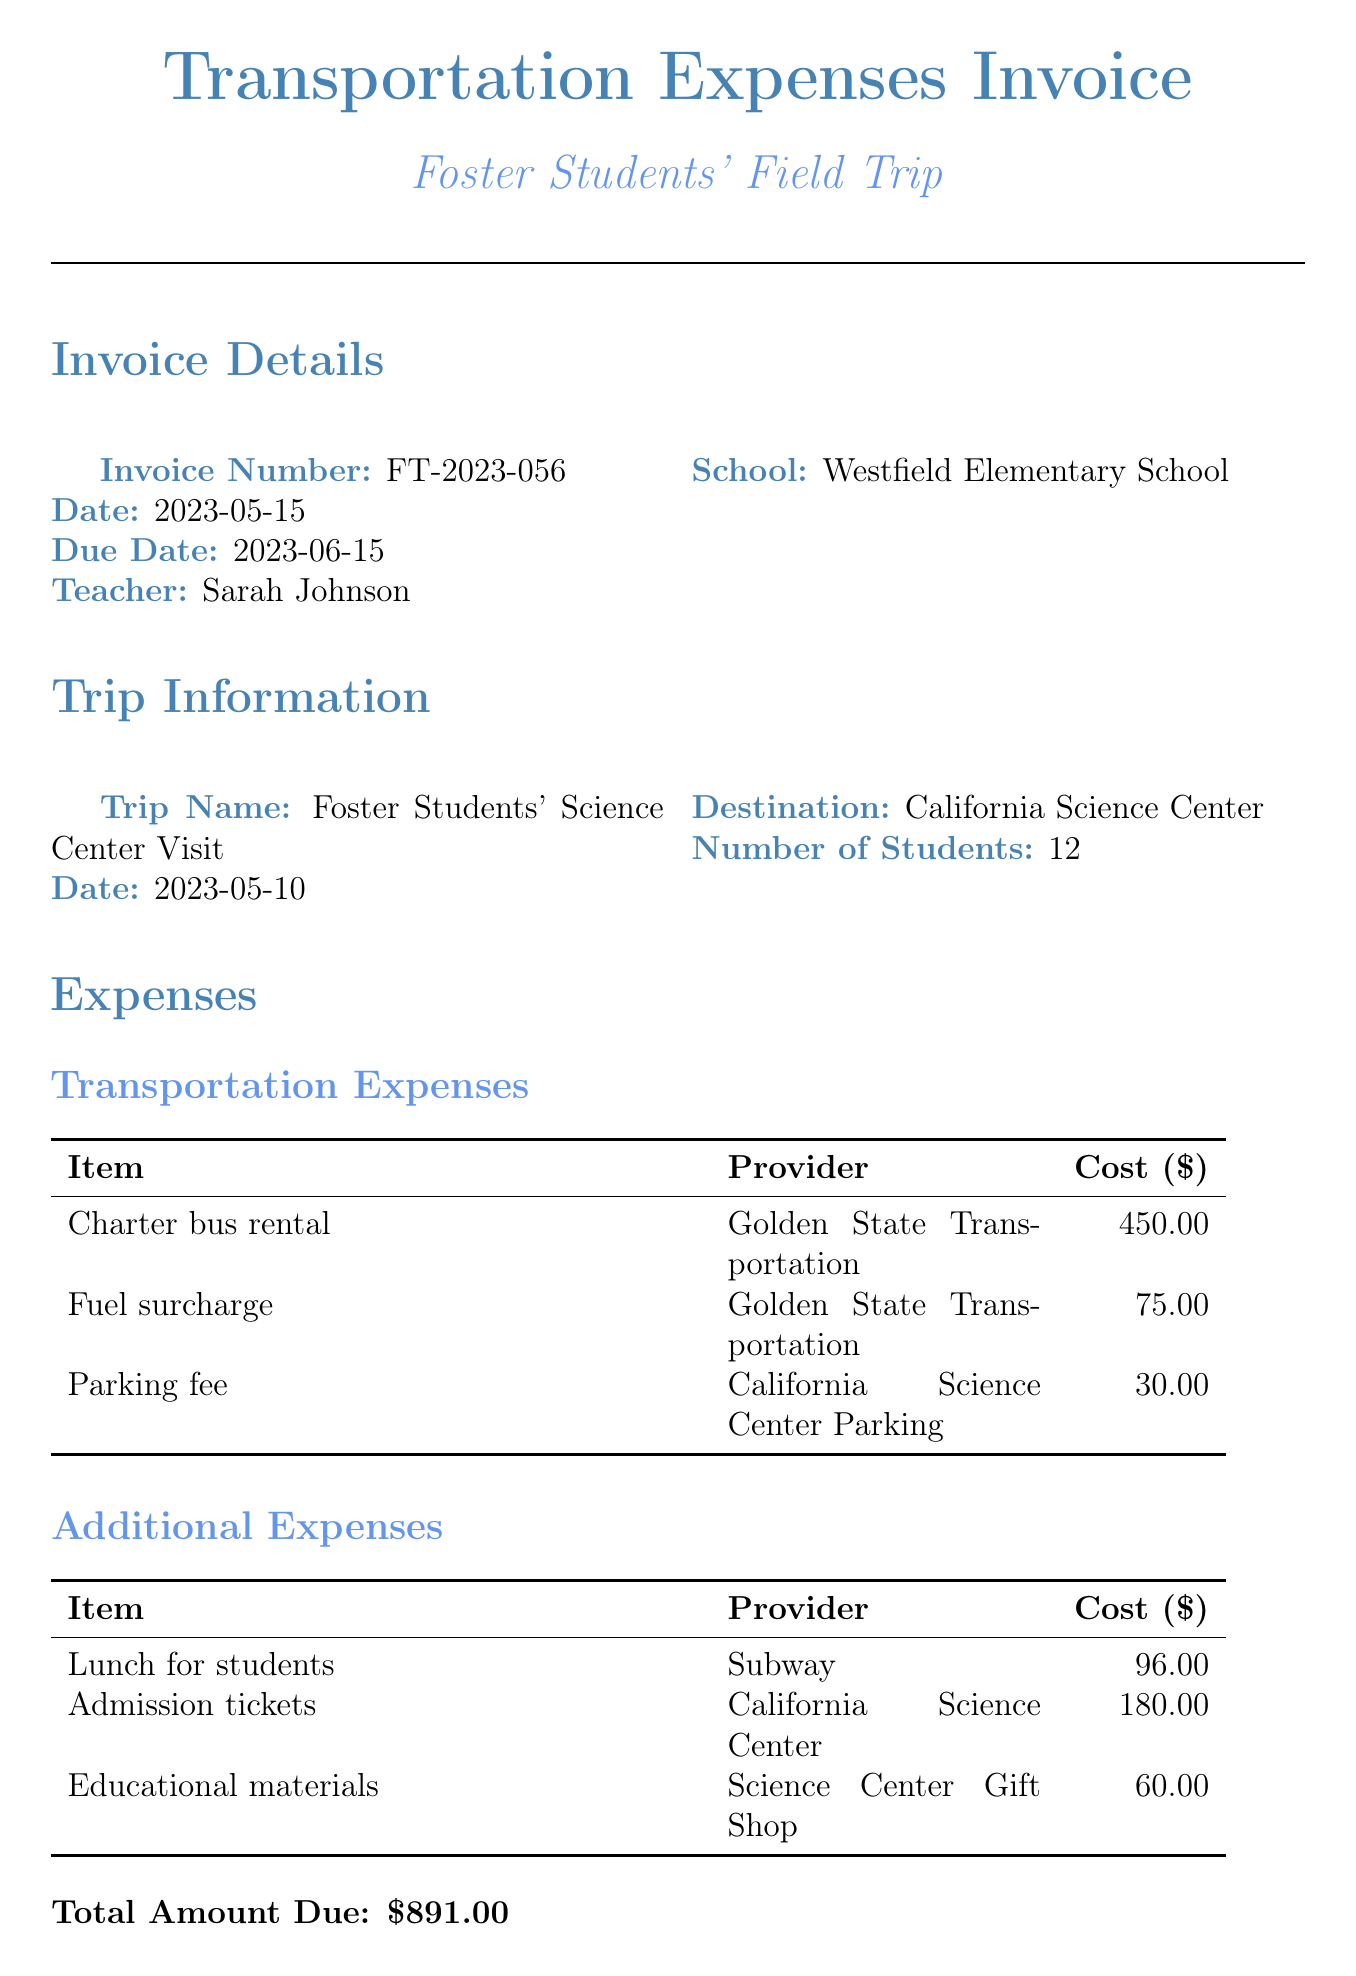What is the invoice number? The invoice number is listed in the invoice details section of the document.
Answer: FT-2023-056 Who organized the field trip? The field trip was organized by Sarah Johnson, as indicated in the invoice.
Answer: Sarah Johnson What is the total amount due? The total amount due is calculated by summing all expenses listed in the document.
Answer: $891.00 How many students attended the trip? The number of students is provided in the trip information section of the document.
Answer: 12 What was the approval date? The approval date is mentioned in the approval information section of the document.
Answer: 2023-05-18 What type of transportation was used? The type of transportation can be found in the transportation expenses subsection of the document.
Answer: Charter bus rental What is the primary purpose of this field trip? The primary purpose is described in the notes section, indicating the educational intention.
Answer: Educational opportunities for foster students Who approved the expenses? The person who approved the expenses is stated in the approval information section.
Answer: Principal Robert Thompson Which bank is used for the direct deposit? The bank name for the reimbursement is specified in the reimbursement details section.
Answer: Wells Fargo 